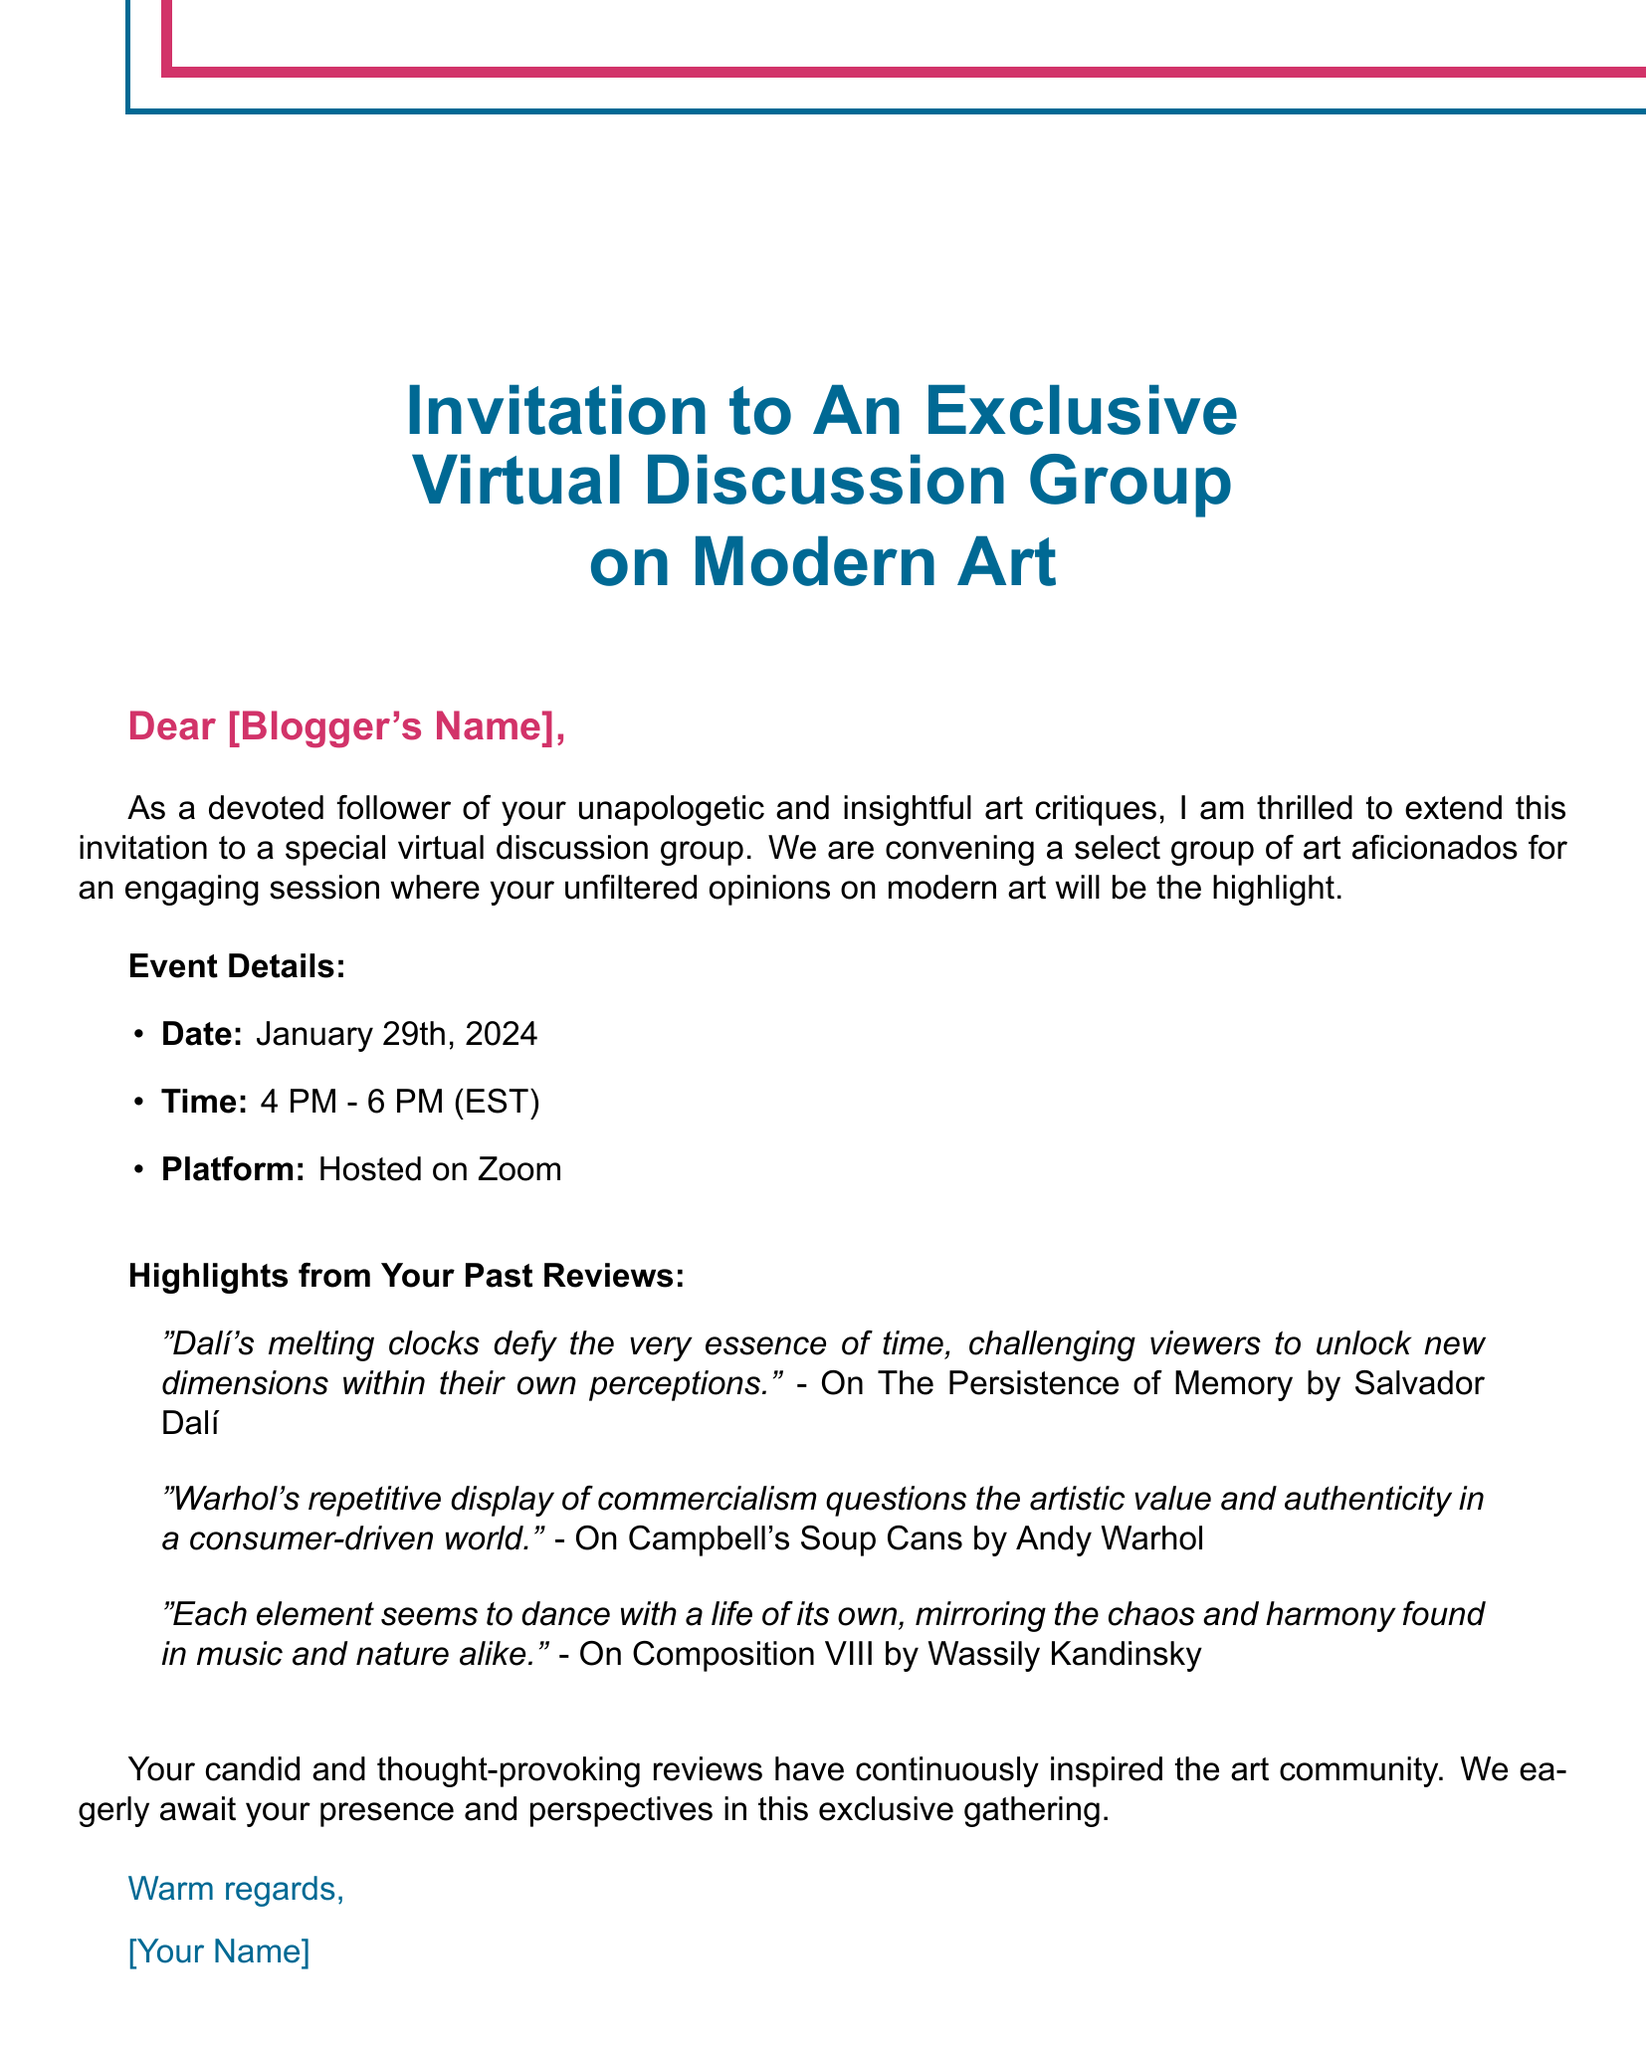What is the date of the event? The document specifies the date of the event as January 29th, 2024.
Answer: January 29th, 2024 What time does the event start? The event details in the document indicate that the event starts at 4 PM.
Answer: 4 PM What platform will the discussion be hosted on? The document mentions that the discussion will be hosted on Zoom.
Answer: Zoom Who is the invitation addressed to? The salutation in the document indicates it is addressed to "[Blogger's Name]."
Answer: [Blogger's Name] What color is used for the title text? The title text is in abstract blue, as specified in the document.
Answer: abstract blue What is the main focus of the virtual discussion group? The document states that the focus will be on the blogger's unfiltered opinions on modern art.
Answer: unfiltered opinions on modern art Which artwork features "melting clocks"? The document includes a quote referencing "The Persistence of Memory" by Salvador Dalí, which features melting clocks.
Answer: The Persistence of Memory What type of document is this? The format and layout suggest that this is an invitation card.
Answer: invitation card What tone does the invitation convey towards the blogger's critiques? The document expresses appreciation for the blogger's unapologetic and insightful critiques.
Answer: appreciation 